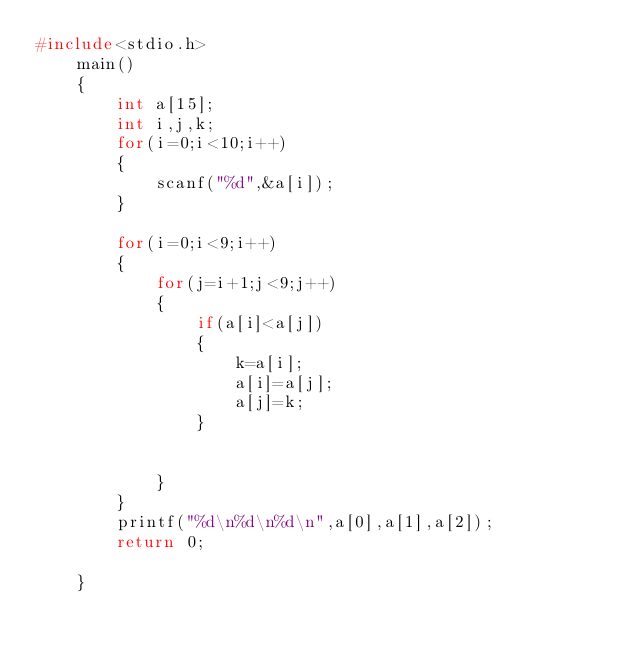Convert code to text. <code><loc_0><loc_0><loc_500><loc_500><_C_>#include<stdio.h>
    main()
    {
        int a[15];
        int i,j,k;
        for(i=0;i<10;i++)
        {
            scanf("%d",&a[i]);
        }

        for(i=0;i<9;i++)
        {
            for(j=i+1;j<9;j++)
            {
                if(a[i]<a[j])
                {
                    k=a[i];
                    a[i]=a[j];
                    a[j]=k;
                }


            }
        }
        printf("%d\n%d\n%d\n",a[0],a[1],a[2]);
        return 0;

    }</code> 